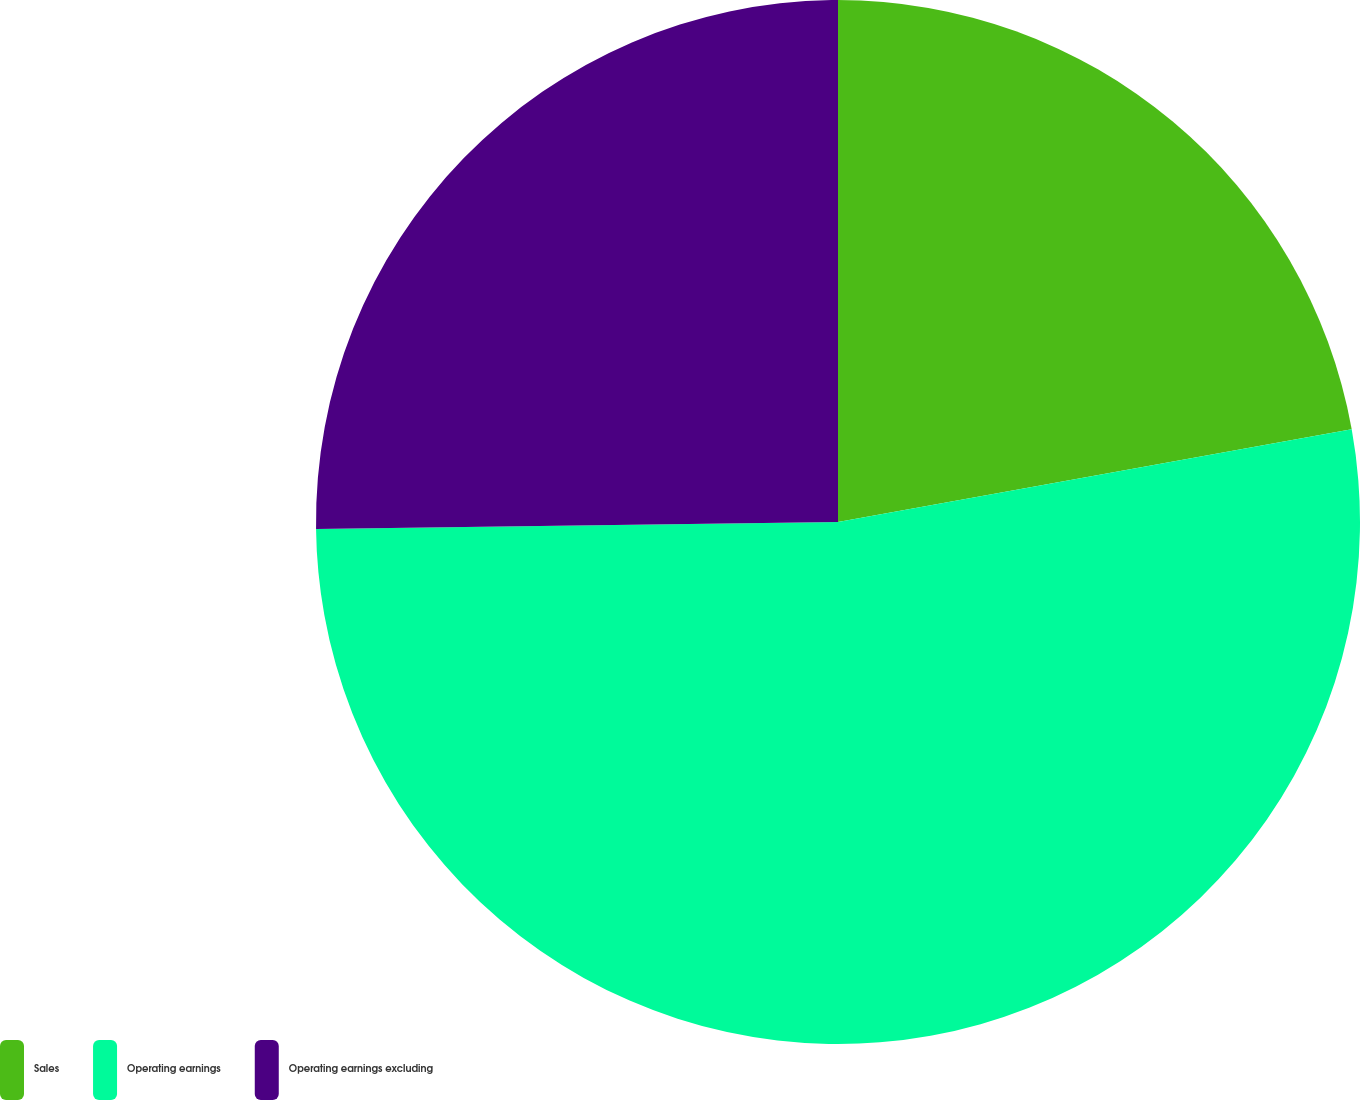<chart> <loc_0><loc_0><loc_500><loc_500><pie_chart><fcel>Sales<fcel>Operating earnings<fcel>Operating earnings excluding<nl><fcel>22.16%<fcel>52.63%<fcel>25.21%<nl></chart> 